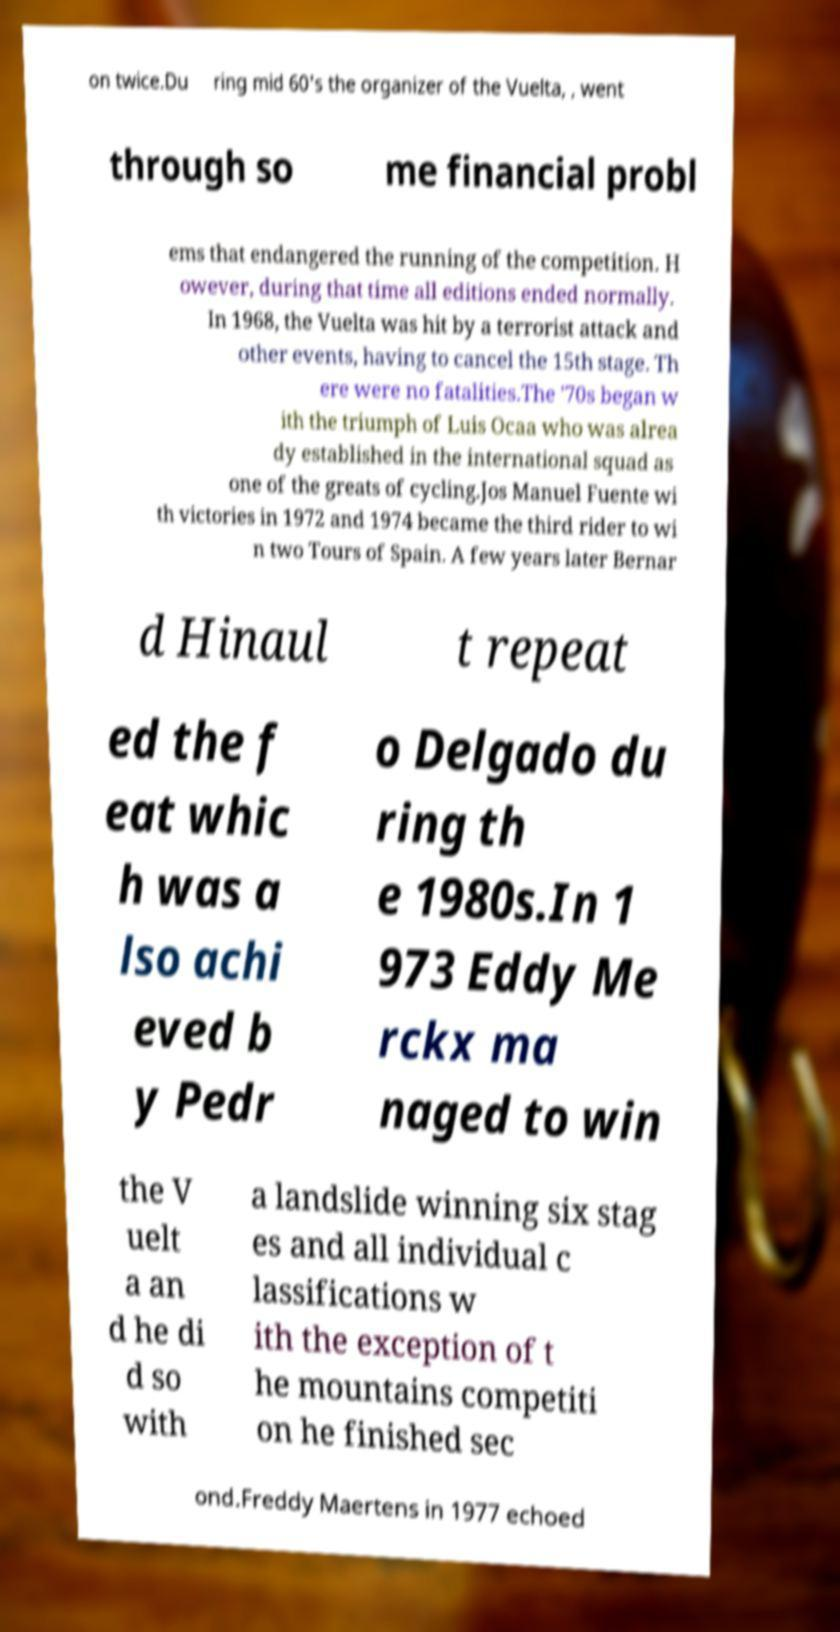Can you read and provide the text displayed in the image?This photo seems to have some interesting text. Can you extract and type it out for me? on twice.Du ring mid 60's the organizer of the Vuelta, , went through so me financial probl ems that endangered the running of the competition. H owever, during that time all editions ended normally. In 1968, the Vuelta was hit by a terrorist attack and other events, having to cancel the 15th stage. Th ere were no fatalities.The '70s began w ith the triumph of Luis Ocaa who was alrea dy established in the international squad as one of the greats of cycling.Jos Manuel Fuente wi th victories in 1972 and 1974 became the third rider to wi n two Tours of Spain. A few years later Bernar d Hinaul t repeat ed the f eat whic h was a lso achi eved b y Pedr o Delgado du ring th e 1980s.In 1 973 Eddy Me rckx ma naged to win the V uelt a an d he di d so with a landslide winning six stag es and all individual c lassifications w ith the exception of t he mountains competiti on he finished sec ond.Freddy Maertens in 1977 echoed 